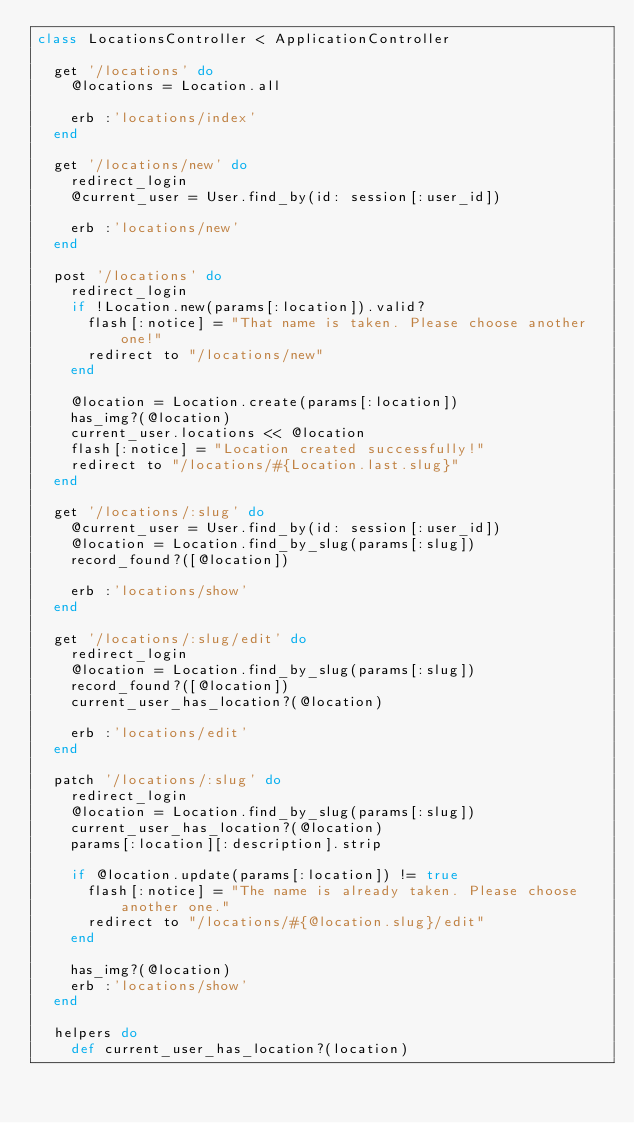<code> <loc_0><loc_0><loc_500><loc_500><_Ruby_>class LocationsController < ApplicationController

  get '/locations' do
    @locations = Location.all

    erb :'locations/index'
  end

  get '/locations/new' do
    redirect_login
    @current_user = User.find_by(id: session[:user_id])

    erb :'locations/new'
  end

  post '/locations' do
    redirect_login
    if !Location.new(params[:location]).valid?                 
      flash[:notice] = "That name is taken. Please choose another one!"
      redirect to "/locations/new"
    end
    
    @location = Location.create(params[:location])
    has_img?(@location)
    current_user.locations << @location
    flash[:notice] = "Location created successfully!"
    redirect to "/locations/#{Location.last.slug}"
  end

  get '/locations/:slug' do
    @current_user = User.find_by(id: session[:user_id])
    @location = Location.find_by_slug(params[:slug])
    record_found?([@location])

    erb :'locations/show'
  end

  get '/locations/:slug/edit' do 
    redirect_login
    @location = Location.find_by_slug(params[:slug])
    record_found?([@location])
    current_user_has_location?(@location)
    
    erb :'locations/edit'
  end

  patch '/locations/:slug' do
    redirect_login
    @location = Location.find_by_slug(params[:slug])
    current_user_has_location?(@location)
    params[:location][:description].strip
    
    if @location.update(params[:location]) != true
      flash[:notice] = "The name is already taken. Please choose another one."
      redirect to "/locations/#{@location.slug}/edit"
    end

    has_img?(@location)
    erb :'locations/show'
  end

  helpers do
    def current_user_has_location?(location)</code> 